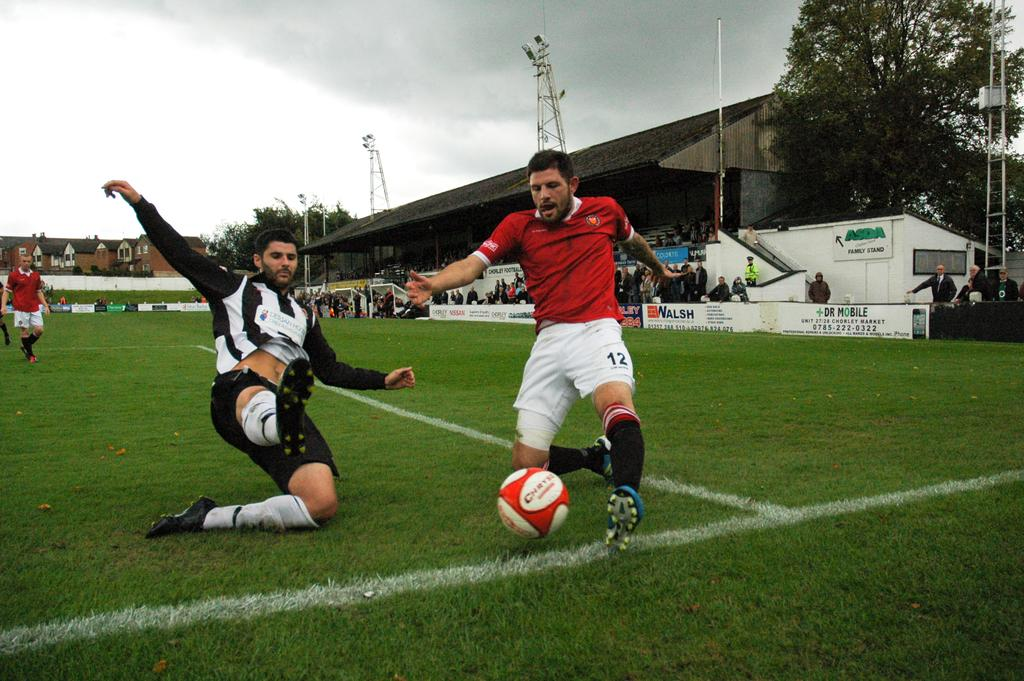<image>
Write a terse but informative summary of the picture. Two men are playing soccer on a field that is sponsored by Dr. Mobile, Asda, and Nissan. 